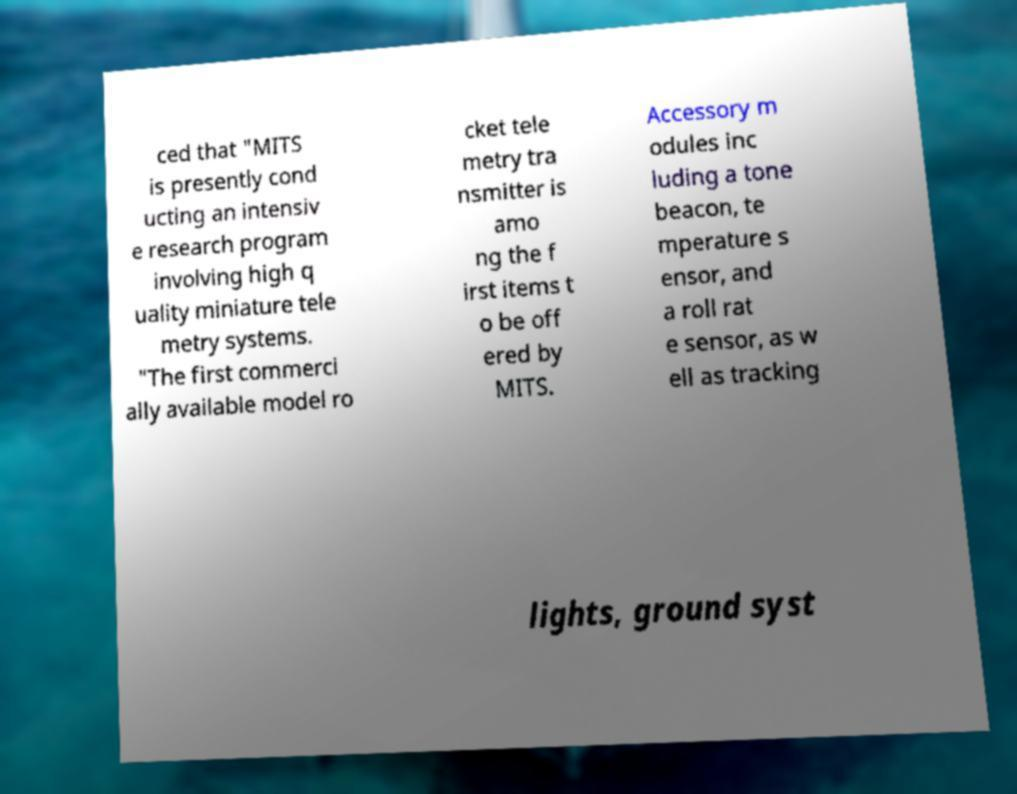Please identify and transcribe the text found in this image. ced that "MITS is presently cond ucting an intensiv e research program involving high q uality miniature tele metry systems. "The first commerci ally available model ro cket tele metry tra nsmitter is amo ng the f irst items t o be off ered by MITS. Accessory m odules inc luding a tone beacon, te mperature s ensor, and a roll rat e sensor, as w ell as tracking lights, ground syst 